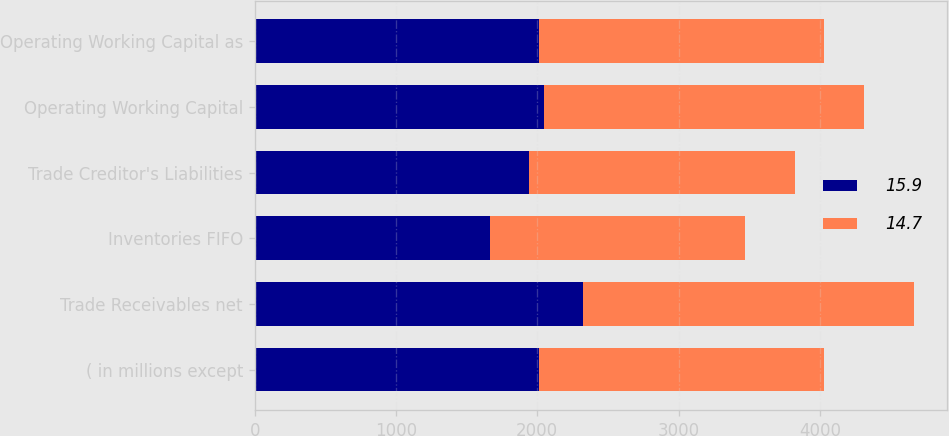Convert chart to OTSL. <chart><loc_0><loc_0><loc_500><loc_500><stacked_bar_chart><ecel><fcel>( in millions except<fcel>Trade Receivables net<fcel>Inventories FIFO<fcel>Trade Creditor's Liabilities<fcel>Operating Working Capital<fcel>Operating Working Capital as<nl><fcel>15.9<fcel>2016<fcel>2324<fcel>1666<fcel>1940<fcel>2050<fcel>2015.5<nl><fcel>14.7<fcel>2015<fcel>2343<fcel>1803<fcel>1886<fcel>2260<fcel>2015.5<nl></chart> 